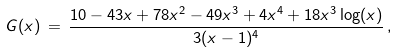<formula> <loc_0><loc_0><loc_500><loc_500>G ( x ) \, = \, \frac { 1 0 - 4 3 x + 7 8 x ^ { 2 } - 4 9 x ^ { 3 } + 4 x ^ { 4 } + 1 8 x ^ { 3 } \log ( x ) } { 3 ( x - 1 ) ^ { 4 } } \, ,</formula> 